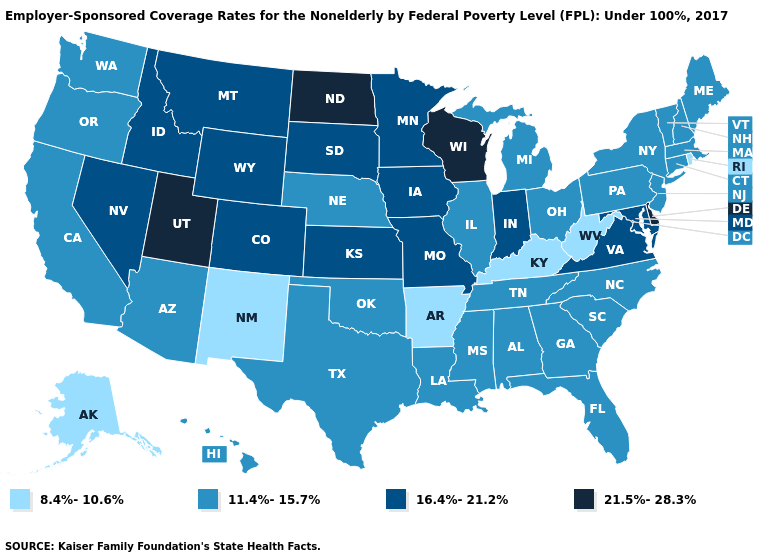Name the states that have a value in the range 16.4%-21.2%?
Be succinct. Colorado, Idaho, Indiana, Iowa, Kansas, Maryland, Minnesota, Missouri, Montana, Nevada, South Dakota, Virginia, Wyoming. Does the first symbol in the legend represent the smallest category?
Short answer required. Yes. Name the states that have a value in the range 8.4%-10.6%?
Keep it brief. Alaska, Arkansas, Kentucky, New Mexico, Rhode Island, West Virginia. Does California have the same value as Alaska?
Answer briefly. No. Name the states that have a value in the range 8.4%-10.6%?
Short answer required. Alaska, Arkansas, Kentucky, New Mexico, Rhode Island, West Virginia. How many symbols are there in the legend?
Concise answer only. 4. What is the value of Oregon?
Be succinct. 11.4%-15.7%. Name the states that have a value in the range 21.5%-28.3%?
Short answer required. Delaware, North Dakota, Utah, Wisconsin. Name the states that have a value in the range 21.5%-28.3%?
Be succinct. Delaware, North Dakota, Utah, Wisconsin. Name the states that have a value in the range 11.4%-15.7%?
Write a very short answer. Alabama, Arizona, California, Connecticut, Florida, Georgia, Hawaii, Illinois, Louisiana, Maine, Massachusetts, Michigan, Mississippi, Nebraska, New Hampshire, New Jersey, New York, North Carolina, Ohio, Oklahoma, Oregon, Pennsylvania, South Carolina, Tennessee, Texas, Vermont, Washington. Among the states that border South Dakota , does Nebraska have the lowest value?
Keep it brief. Yes. What is the highest value in the USA?
Quick response, please. 21.5%-28.3%. Which states hav the highest value in the Northeast?
Give a very brief answer. Connecticut, Maine, Massachusetts, New Hampshire, New Jersey, New York, Pennsylvania, Vermont. Which states have the lowest value in the MidWest?
Write a very short answer. Illinois, Michigan, Nebraska, Ohio. 